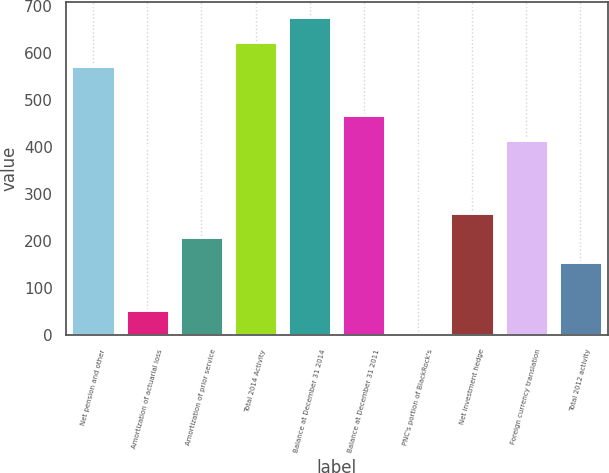Convert chart to OTSL. <chart><loc_0><loc_0><loc_500><loc_500><bar_chart><fcel>Net pension and other<fcel>Amortization of actuarial loss<fcel>Amortization of prior service<fcel>Total 2014 Activity<fcel>Balance at December 31 2014<fcel>Balance at December 31 2011<fcel>PNC's portion of BlackRock's<fcel>Net investment hedge<fcel>Foreign currency translation<fcel>Total 2012 activity<nl><fcel>571.9<fcel>52.9<fcel>208.6<fcel>623.8<fcel>675.7<fcel>468.1<fcel>1<fcel>260.5<fcel>416.2<fcel>156.7<nl></chart> 